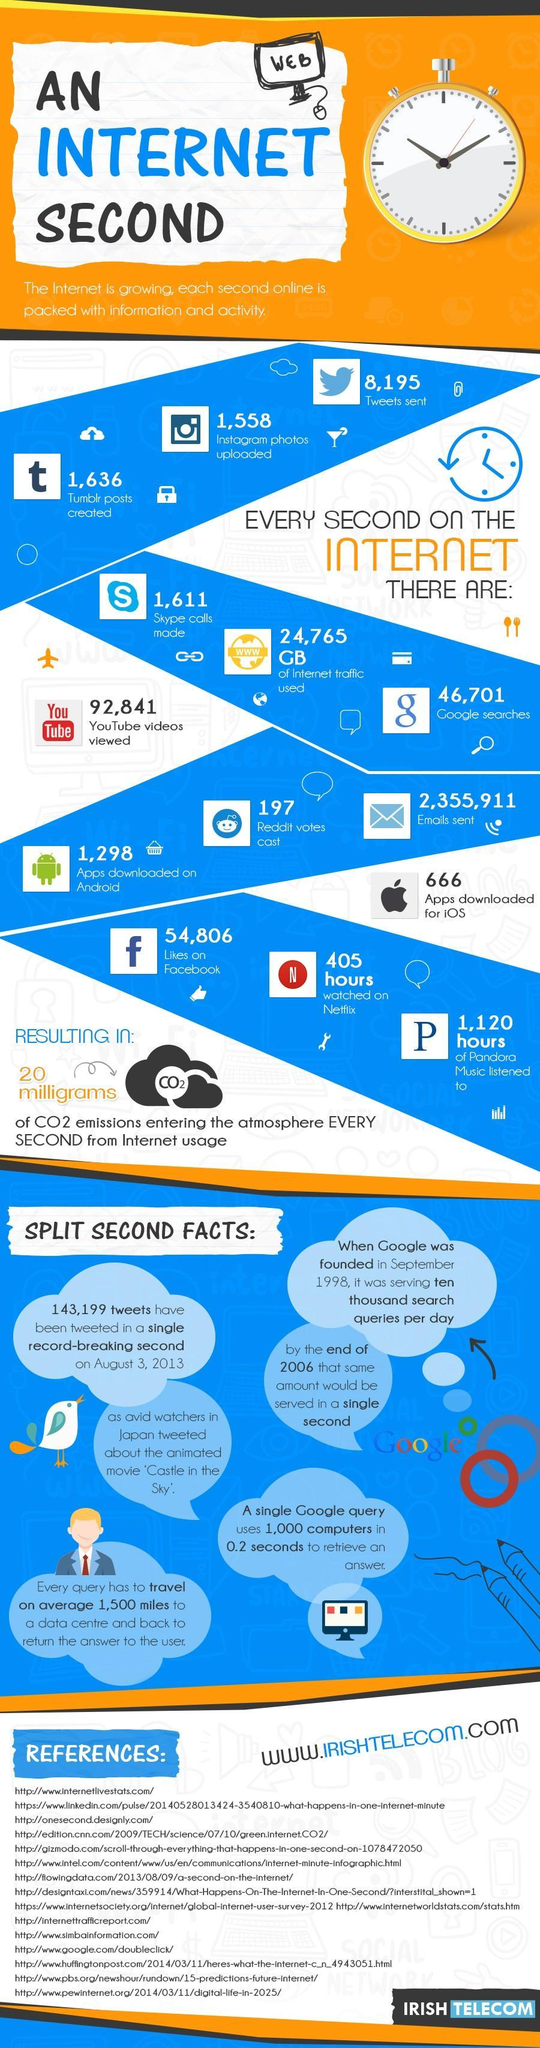How many google searches are done in each second?
Answer the question with a short phrase. 46,701 What is the number of youtube videos viewed every second on the internet? 92,841 How many apps were downloaded in Apple iOS in each second? 666 What is the number of emails sent every second on the internet? 2,355,911 How many apps were downloaded in Android in each second on the internet? 1,298 How many instagram photos were uploaded every second on the internet? 1,558 